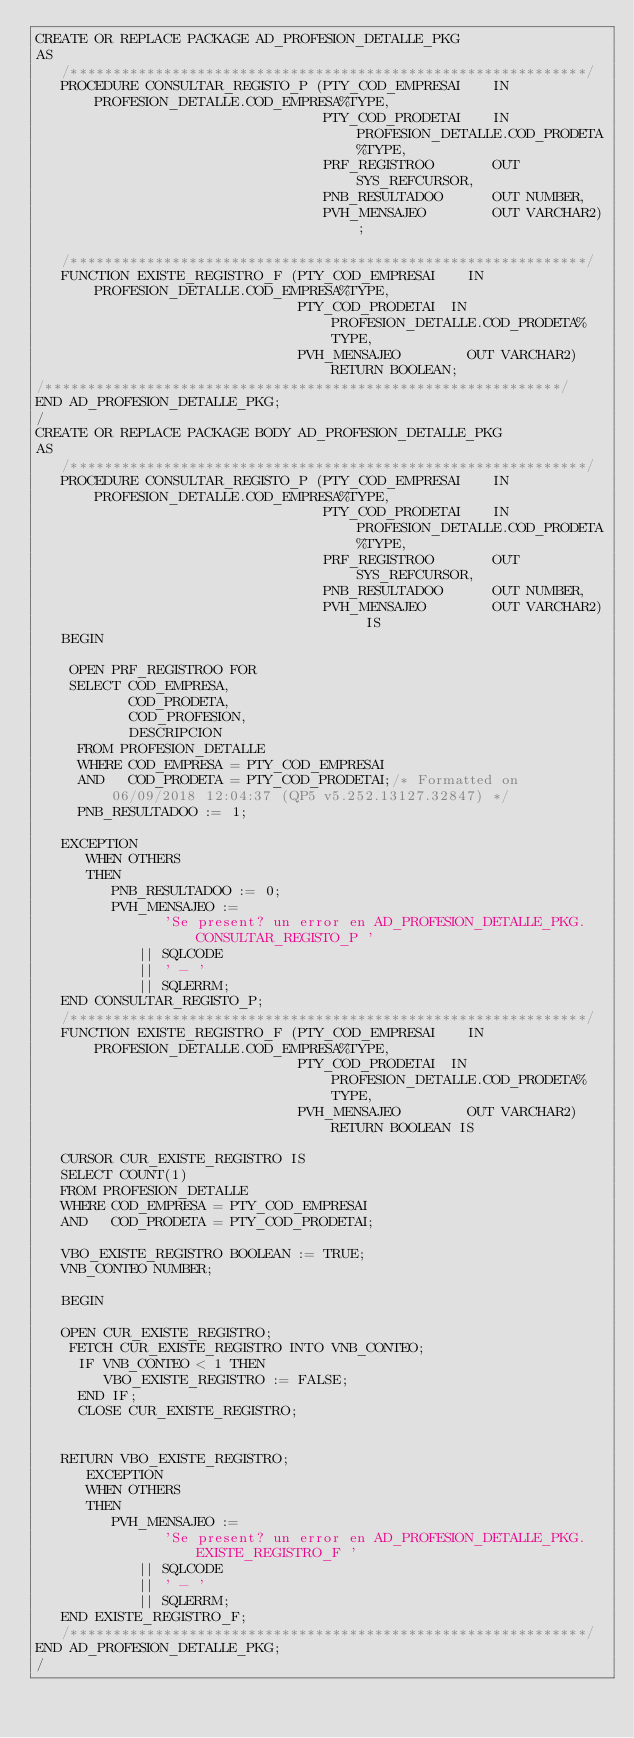<code> <loc_0><loc_0><loc_500><loc_500><_SQL_>CREATE OR REPLACE PACKAGE AD_PROFESION_DETALLE_PKG
AS
   /*************************************************************/
   PROCEDURE CONSULTAR_REGISTO_P (PTY_COD_EMPRESAI    IN PROFESION_DETALLE.COD_EMPRESA%TYPE,
                                  PTY_COD_PRODETAI    IN PROFESION_DETALLE.COD_PRODETA%TYPE,
                                  PRF_REGISTROO       OUT SYS_REFCURSOR,
                                  PNB_RESULTADOO      OUT NUMBER,
                                  PVH_MENSAJEO        OUT VARCHAR2);

   /*************************************************************/
   FUNCTION EXISTE_REGISTRO_F (PTY_COD_EMPRESAI    IN PROFESION_DETALLE.COD_EMPRESA%TYPE,
                               PTY_COD_PRODETAI  IN PROFESION_DETALLE.COD_PRODETA%TYPE,
                               PVH_MENSAJEO        OUT VARCHAR2) RETURN BOOLEAN;
/*************************************************************/
END AD_PROFESION_DETALLE_PKG;
/
CREATE OR REPLACE PACKAGE BODY AD_PROFESION_DETALLE_PKG
AS
   /*************************************************************/
   PROCEDURE CONSULTAR_REGISTO_P (PTY_COD_EMPRESAI    IN PROFESION_DETALLE.COD_EMPRESA%TYPE,
                                  PTY_COD_PRODETAI    IN PROFESION_DETALLE.COD_PRODETA%TYPE,
                                  PRF_REGISTROO       OUT SYS_REFCURSOR,
                                  PNB_RESULTADOO      OUT NUMBER,
                                  PVH_MENSAJEO        OUT VARCHAR2) IS
   BEGIN
   
    OPEN PRF_REGISTROO FOR 
    SELECT COD_EMPRESA,
           COD_PRODETA,
           COD_PROFESION,
           DESCRIPCION
     FROM PROFESION_DETALLE
     WHERE COD_EMPRESA = PTY_COD_EMPRESAI
     AND   COD_PRODETA = PTY_COD_PRODETAI;/* Formatted on 06/09/2018 12:04:37 (QP5 v5.252.13127.32847) */
     PNB_RESULTADOO := 1;
   
   EXCEPTION
      WHEN OTHERS
      THEN
         PNB_RESULTADOO := 0;
         PVH_MENSAJEO :=
               'Se present? un error en AD_PROFESION_DETALLE_PKG.CONSULTAR_REGISTO_P '
            || SQLCODE
            || ' - '
            || SQLERRM; 
   END CONSULTAR_REGISTO_P;           
   /*************************************************************/
   FUNCTION EXISTE_REGISTRO_F (PTY_COD_EMPRESAI    IN PROFESION_DETALLE.COD_EMPRESA%TYPE,
                               PTY_COD_PRODETAI  IN PROFESION_DETALLE.COD_PRODETA%TYPE,
                               PVH_MENSAJEO        OUT VARCHAR2) RETURN BOOLEAN IS 
  
   CURSOR CUR_EXISTE_REGISTRO IS
   SELECT COUNT(1)
   FROM PROFESION_DETALLE
   WHERE COD_EMPRESA = PTY_COD_EMPRESAI
   AND   COD_PRODETA = PTY_COD_PRODETAI;
   
   VBO_EXISTE_REGISTRO BOOLEAN := TRUE;
   VNB_CONTEO NUMBER;
   
   BEGIN
              
   OPEN CUR_EXISTE_REGISTRO;
    FETCH CUR_EXISTE_REGISTRO INTO VNB_CONTEO;
     IF VNB_CONTEO < 1 THEN
        VBO_EXISTE_REGISTRO := FALSE;
     END IF;
     CLOSE CUR_EXISTE_REGISTRO;
        
   
   RETURN VBO_EXISTE_REGISTRO;
      EXCEPTION
      WHEN OTHERS
      THEN
         PVH_MENSAJEO :=
               'Se present? un error en AD_PROFESION_DETALLE_PKG.EXISTE_REGISTRO_F '
            || SQLCODE
            || ' - '
            || SQLERRM;                     
   END EXISTE_REGISTRO_F;
   /*************************************************************/
END AD_PROFESION_DETALLE_PKG;
/
</code> 